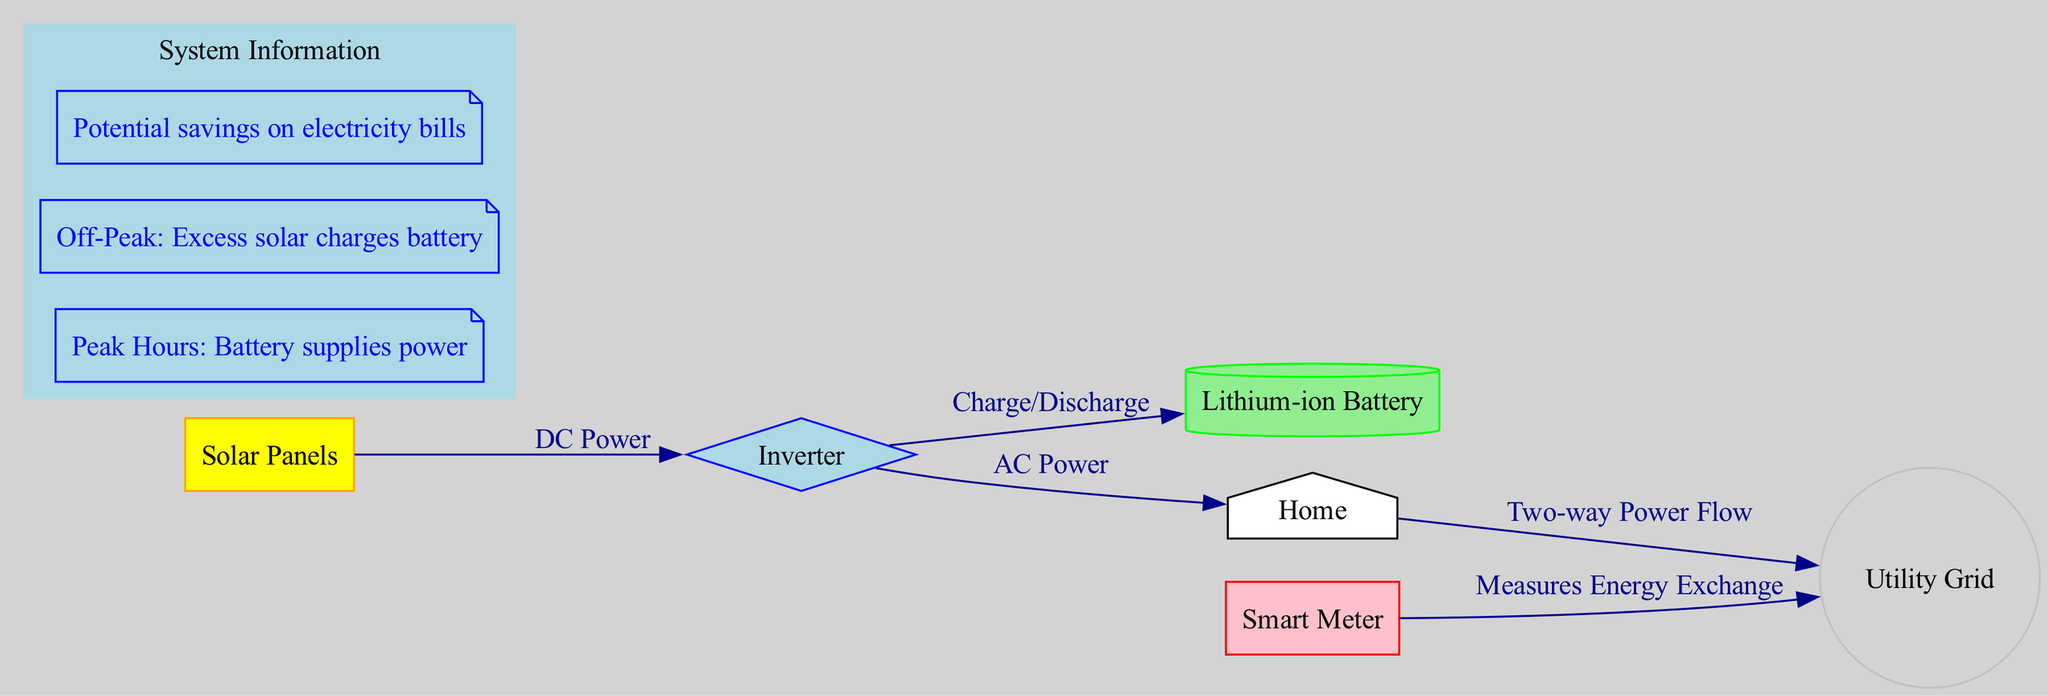What is the main function of the inverter in this system? The inverter converts DC power generated by the solar panels into AC power used in the home. This can be inferred from the connection between the solar panels and the inverter, which shows the flow of DC power.
Answer: AC Power How many nodes are present in the diagram? Counting the nodes labeled as Solar Panels, Inverter, Lithium-ion Battery, Home, Utility Grid, and Smart Meter, there are six distinct nodes.
Answer: 6 What does the battery supply power to during peak hours? According to the annotation labeled "Peak Hours: Battery supplies power," the battery supplies power to the home during peak hours.
Answer: Home What type of power do the solar panels produce? The connection from the solar panels to the inverter indicates the energy type as DC power, which is specifically noted in the edge label.
Answer: DC Power What happens to excess solar energy during off-peak hours? The annotation "Off-Peak: Excess solar charges battery" details that during off-peak hours, any excess energy generated by the solar panels is used to charge the battery.
Answer: Charges Battery How does the Smart Meter function within this system? The Smart Meter measures energy exchange between the home and the grid, as described in the corresponding edge connecting it to the grid, indicating its role in tracking energy flows.
Answer: Measures Energy Exchange During off-peak hours, what is the primary benefit of using the battery? The annotation "Potential savings on electricity bills" emphasizes that using the battery during off-peak hours leads to potential savings, as it reduces reliance on the grid.
Answer: Savings on electricity bills Which component has a two-way power flow with the home? The edge labeled "Two-way Power Flow" between the home and the grid indicates that the grid and home exchange energy in both directions.
Answer: Utility Grid In what form is the energy produced by solar panels initially? The diagram specifies that energy produced by solar panels is DC power, which is highlighted in the edge label connecting the solar panels to the inverter.
Answer: DC Power 